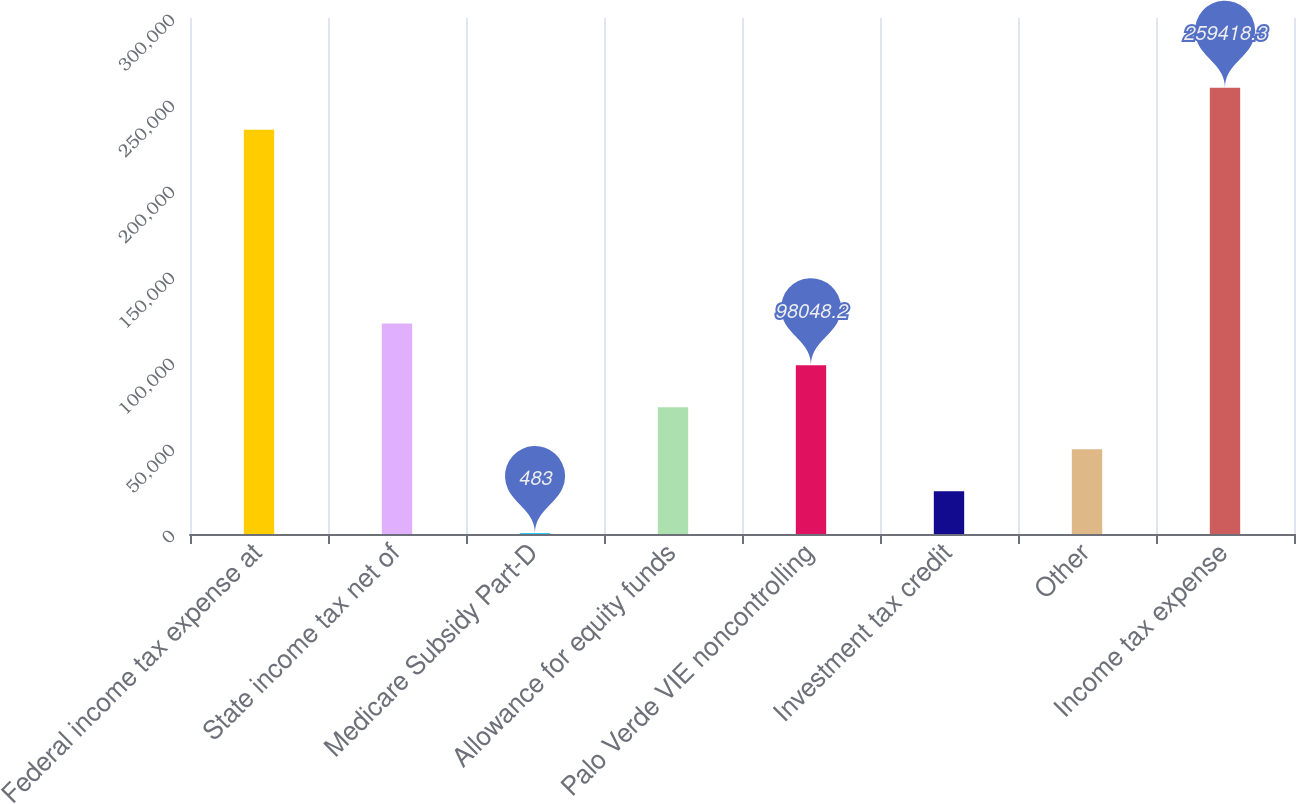Convert chart. <chart><loc_0><loc_0><loc_500><loc_500><bar_chart><fcel>Federal income tax expense at<fcel>State income tax net of<fcel>Medicare Subsidy Part-D<fcel>Allowance for equity funds<fcel>Palo Verde VIE noncontrolling<fcel>Investment tax credit<fcel>Other<fcel>Income tax expense<nl><fcel>235027<fcel>122440<fcel>483<fcel>73656.9<fcel>98048.2<fcel>24874.3<fcel>49265.6<fcel>259418<nl></chart> 